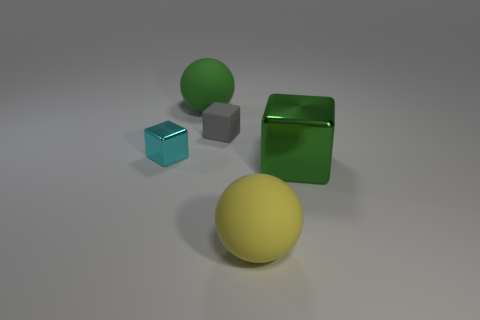What is the shape of the thing that is both on the left side of the gray rubber thing and right of the tiny metallic cube?
Keep it short and to the point. Sphere. What is the color of the metal object on the left side of the big yellow ball?
Ensure brevity in your answer.  Cyan. What size is the object that is left of the tiny rubber thing and behind the tiny cyan object?
Provide a short and direct response. Large. Are the tiny gray thing and the big green thing that is to the left of the gray thing made of the same material?
Provide a succinct answer. Yes. How many other large objects have the same shape as the yellow object?
Offer a very short reply. 1. What number of green cubes are there?
Ensure brevity in your answer.  1. Do the tiny cyan thing and the shiny object on the right side of the large yellow sphere have the same shape?
Keep it short and to the point. Yes. How many objects are purple blocks or objects that are in front of the tiny metallic cube?
Give a very brief answer. 2. There is a cyan thing that is the same shape as the big green metallic thing; what is it made of?
Make the answer very short. Metal. Is the shape of the green object that is to the right of the tiny gray object the same as  the large yellow thing?
Offer a terse response. No. 